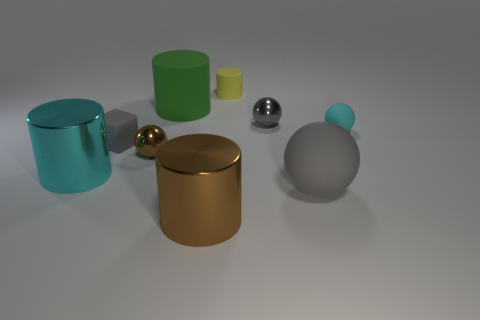Do the small cyan object and the large object that is to the left of the green rubber cylinder have the same material?
Ensure brevity in your answer.  No. How many other objects are the same shape as the small yellow rubber thing?
Keep it short and to the point. 3. How many objects are tiny metallic balls on the left side of the green matte thing or balls right of the brown metal sphere?
Make the answer very short. 4. How many other objects are the same color as the tiny block?
Make the answer very short. 2. Is the number of green things in front of the tiny cyan rubber thing less than the number of objects that are behind the large rubber sphere?
Keep it short and to the point. Yes. How many gray spheres are there?
Offer a very short reply. 2. There is a cyan thing that is the same shape as the big green object; what is its material?
Your answer should be compact. Metal. Is the number of brown metal objects that are behind the large cyan cylinder less than the number of cyan objects?
Your answer should be very brief. Yes. Does the tiny rubber thing that is on the right side of the big rubber sphere have the same shape as the small brown object?
Your response must be concise. Yes. Is there anything else that has the same color as the large rubber cylinder?
Your response must be concise. No. 